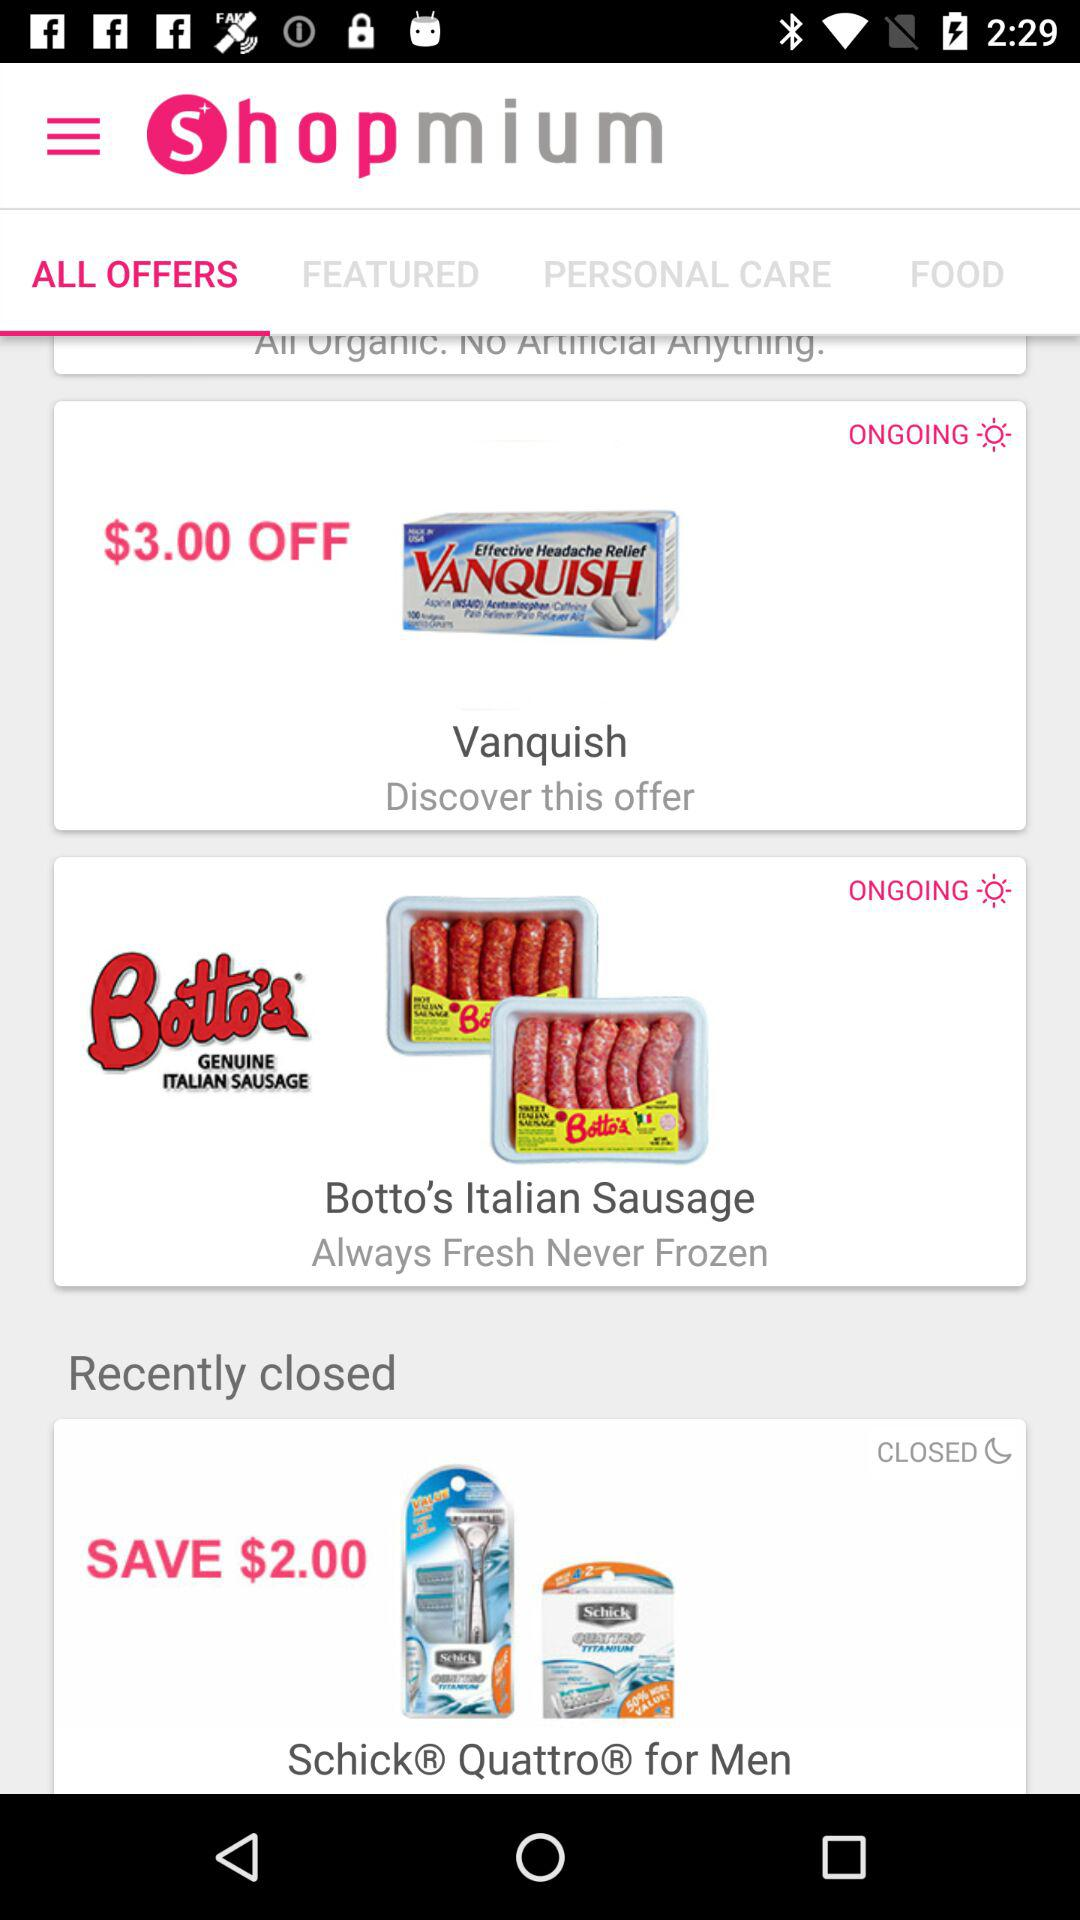How many offers are ongoing?
Answer the question using a single word or phrase. 2 